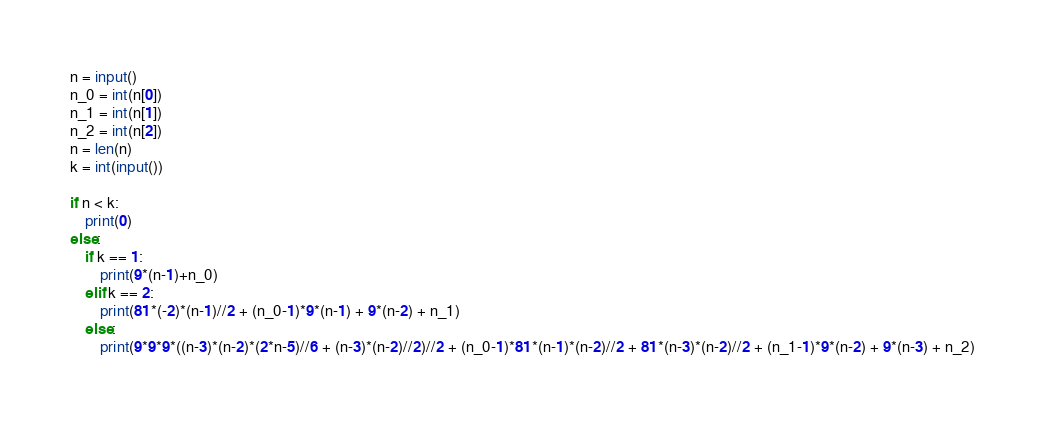<code> <loc_0><loc_0><loc_500><loc_500><_Python_>n = input()
n_0 = int(n[0])
n_1 = int(n[1])
n_2 = int(n[2])
n = len(n)
k = int(input())

if n < k:
    print(0)
else:
    if k == 1:
        print(9*(n-1)+n_0)
    elif k == 2:
        print(81*(-2)*(n-1)//2 + (n_0-1)*9*(n-1) + 9*(n-2) + n_1)
    else:
        print(9*9*9*((n-3)*(n-2)*(2*n-5)//6 + (n-3)*(n-2)//2)//2 + (n_0-1)*81*(n-1)*(n-2)//2 + 81*(n-3)*(n-2)//2 + (n_1-1)*9*(n-2) + 9*(n-3) + n_2)</code> 